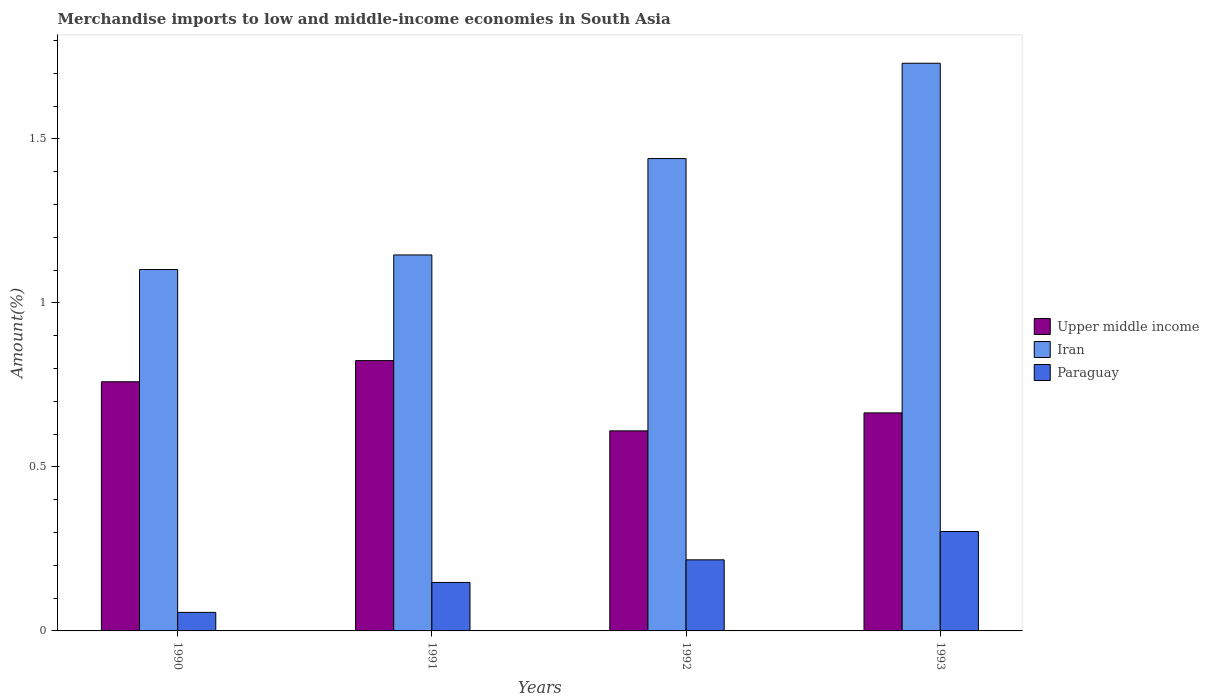How many different coloured bars are there?
Provide a short and direct response. 3. How many groups of bars are there?
Provide a short and direct response. 4. Are the number of bars per tick equal to the number of legend labels?
Offer a very short reply. Yes. Are the number of bars on each tick of the X-axis equal?
Your answer should be very brief. Yes. How many bars are there on the 3rd tick from the right?
Ensure brevity in your answer.  3. What is the percentage of amount earned from merchandise imports in Paraguay in 1990?
Your response must be concise. 0.06. Across all years, what is the maximum percentage of amount earned from merchandise imports in Paraguay?
Make the answer very short. 0.3. Across all years, what is the minimum percentage of amount earned from merchandise imports in Iran?
Offer a terse response. 1.1. In which year was the percentage of amount earned from merchandise imports in Iran maximum?
Your answer should be compact. 1993. What is the total percentage of amount earned from merchandise imports in Iran in the graph?
Offer a very short reply. 5.42. What is the difference between the percentage of amount earned from merchandise imports in Upper middle income in 1991 and that in 1992?
Keep it short and to the point. 0.21. What is the difference between the percentage of amount earned from merchandise imports in Paraguay in 1991 and the percentage of amount earned from merchandise imports in Upper middle income in 1990?
Offer a very short reply. -0.61. What is the average percentage of amount earned from merchandise imports in Iran per year?
Give a very brief answer. 1.35. In the year 1992, what is the difference between the percentage of amount earned from merchandise imports in Iran and percentage of amount earned from merchandise imports in Paraguay?
Your answer should be compact. 1.22. What is the ratio of the percentage of amount earned from merchandise imports in Upper middle income in 1990 to that in 1992?
Offer a terse response. 1.25. Is the percentage of amount earned from merchandise imports in Iran in 1992 less than that in 1993?
Make the answer very short. Yes. Is the difference between the percentage of amount earned from merchandise imports in Iran in 1990 and 1992 greater than the difference between the percentage of amount earned from merchandise imports in Paraguay in 1990 and 1992?
Provide a succinct answer. No. What is the difference between the highest and the second highest percentage of amount earned from merchandise imports in Iran?
Give a very brief answer. 0.29. What is the difference between the highest and the lowest percentage of amount earned from merchandise imports in Paraguay?
Give a very brief answer. 0.25. In how many years, is the percentage of amount earned from merchandise imports in Upper middle income greater than the average percentage of amount earned from merchandise imports in Upper middle income taken over all years?
Your answer should be compact. 2. Is the sum of the percentage of amount earned from merchandise imports in Upper middle income in 1990 and 1992 greater than the maximum percentage of amount earned from merchandise imports in Iran across all years?
Your response must be concise. No. What does the 2nd bar from the left in 1990 represents?
Your answer should be very brief. Iran. What does the 2nd bar from the right in 1992 represents?
Provide a short and direct response. Iran. Is it the case that in every year, the sum of the percentage of amount earned from merchandise imports in Paraguay and percentage of amount earned from merchandise imports in Upper middle income is greater than the percentage of amount earned from merchandise imports in Iran?
Offer a very short reply. No. How many bars are there?
Offer a very short reply. 12. Are the values on the major ticks of Y-axis written in scientific E-notation?
Offer a very short reply. No. How are the legend labels stacked?
Your response must be concise. Vertical. What is the title of the graph?
Give a very brief answer. Merchandise imports to low and middle-income economies in South Asia. Does "Slovak Republic" appear as one of the legend labels in the graph?
Provide a succinct answer. No. What is the label or title of the X-axis?
Provide a succinct answer. Years. What is the label or title of the Y-axis?
Give a very brief answer. Amount(%). What is the Amount(%) of Upper middle income in 1990?
Give a very brief answer. 0.76. What is the Amount(%) in Iran in 1990?
Your response must be concise. 1.1. What is the Amount(%) in Paraguay in 1990?
Your answer should be compact. 0.06. What is the Amount(%) of Upper middle income in 1991?
Offer a very short reply. 0.82. What is the Amount(%) in Iran in 1991?
Your response must be concise. 1.15. What is the Amount(%) in Paraguay in 1991?
Keep it short and to the point. 0.15. What is the Amount(%) of Upper middle income in 1992?
Offer a terse response. 0.61. What is the Amount(%) of Iran in 1992?
Provide a short and direct response. 1.44. What is the Amount(%) of Paraguay in 1992?
Provide a short and direct response. 0.22. What is the Amount(%) of Upper middle income in 1993?
Your answer should be compact. 0.66. What is the Amount(%) of Iran in 1993?
Offer a terse response. 1.73. What is the Amount(%) in Paraguay in 1993?
Provide a short and direct response. 0.3. Across all years, what is the maximum Amount(%) of Upper middle income?
Your answer should be compact. 0.82. Across all years, what is the maximum Amount(%) in Iran?
Your answer should be compact. 1.73. Across all years, what is the maximum Amount(%) of Paraguay?
Offer a very short reply. 0.3. Across all years, what is the minimum Amount(%) of Upper middle income?
Ensure brevity in your answer.  0.61. Across all years, what is the minimum Amount(%) of Iran?
Your response must be concise. 1.1. Across all years, what is the minimum Amount(%) in Paraguay?
Your answer should be very brief. 0.06. What is the total Amount(%) of Upper middle income in the graph?
Your response must be concise. 2.86. What is the total Amount(%) of Iran in the graph?
Keep it short and to the point. 5.42. What is the total Amount(%) in Paraguay in the graph?
Offer a very short reply. 0.72. What is the difference between the Amount(%) in Upper middle income in 1990 and that in 1991?
Provide a short and direct response. -0.06. What is the difference between the Amount(%) of Iran in 1990 and that in 1991?
Ensure brevity in your answer.  -0.04. What is the difference between the Amount(%) of Paraguay in 1990 and that in 1991?
Offer a terse response. -0.09. What is the difference between the Amount(%) in Upper middle income in 1990 and that in 1992?
Give a very brief answer. 0.15. What is the difference between the Amount(%) in Iran in 1990 and that in 1992?
Ensure brevity in your answer.  -0.34. What is the difference between the Amount(%) of Paraguay in 1990 and that in 1992?
Provide a short and direct response. -0.16. What is the difference between the Amount(%) of Upper middle income in 1990 and that in 1993?
Your answer should be compact. 0.09. What is the difference between the Amount(%) of Iran in 1990 and that in 1993?
Your answer should be very brief. -0.63. What is the difference between the Amount(%) of Paraguay in 1990 and that in 1993?
Your answer should be very brief. -0.25. What is the difference between the Amount(%) in Upper middle income in 1991 and that in 1992?
Your answer should be compact. 0.21. What is the difference between the Amount(%) of Iran in 1991 and that in 1992?
Your answer should be compact. -0.29. What is the difference between the Amount(%) of Paraguay in 1991 and that in 1992?
Offer a very short reply. -0.07. What is the difference between the Amount(%) of Upper middle income in 1991 and that in 1993?
Offer a very short reply. 0.16. What is the difference between the Amount(%) of Iran in 1991 and that in 1993?
Give a very brief answer. -0.58. What is the difference between the Amount(%) in Paraguay in 1991 and that in 1993?
Your response must be concise. -0.16. What is the difference between the Amount(%) in Upper middle income in 1992 and that in 1993?
Your answer should be very brief. -0.05. What is the difference between the Amount(%) of Iran in 1992 and that in 1993?
Offer a terse response. -0.29. What is the difference between the Amount(%) of Paraguay in 1992 and that in 1993?
Offer a terse response. -0.09. What is the difference between the Amount(%) of Upper middle income in 1990 and the Amount(%) of Iran in 1991?
Offer a terse response. -0.39. What is the difference between the Amount(%) in Upper middle income in 1990 and the Amount(%) in Paraguay in 1991?
Make the answer very short. 0.61. What is the difference between the Amount(%) in Iran in 1990 and the Amount(%) in Paraguay in 1991?
Keep it short and to the point. 0.95. What is the difference between the Amount(%) of Upper middle income in 1990 and the Amount(%) of Iran in 1992?
Your answer should be compact. -0.68. What is the difference between the Amount(%) of Upper middle income in 1990 and the Amount(%) of Paraguay in 1992?
Your answer should be very brief. 0.54. What is the difference between the Amount(%) in Iran in 1990 and the Amount(%) in Paraguay in 1992?
Your answer should be very brief. 0.89. What is the difference between the Amount(%) in Upper middle income in 1990 and the Amount(%) in Iran in 1993?
Provide a succinct answer. -0.97. What is the difference between the Amount(%) of Upper middle income in 1990 and the Amount(%) of Paraguay in 1993?
Offer a terse response. 0.46. What is the difference between the Amount(%) of Iran in 1990 and the Amount(%) of Paraguay in 1993?
Provide a succinct answer. 0.8. What is the difference between the Amount(%) of Upper middle income in 1991 and the Amount(%) of Iran in 1992?
Your response must be concise. -0.62. What is the difference between the Amount(%) in Upper middle income in 1991 and the Amount(%) in Paraguay in 1992?
Offer a terse response. 0.61. What is the difference between the Amount(%) in Iran in 1991 and the Amount(%) in Paraguay in 1992?
Your answer should be compact. 0.93. What is the difference between the Amount(%) in Upper middle income in 1991 and the Amount(%) in Iran in 1993?
Your response must be concise. -0.91. What is the difference between the Amount(%) in Upper middle income in 1991 and the Amount(%) in Paraguay in 1993?
Provide a short and direct response. 0.52. What is the difference between the Amount(%) of Iran in 1991 and the Amount(%) of Paraguay in 1993?
Keep it short and to the point. 0.84. What is the difference between the Amount(%) in Upper middle income in 1992 and the Amount(%) in Iran in 1993?
Offer a terse response. -1.12. What is the difference between the Amount(%) of Upper middle income in 1992 and the Amount(%) of Paraguay in 1993?
Provide a short and direct response. 0.31. What is the difference between the Amount(%) of Iran in 1992 and the Amount(%) of Paraguay in 1993?
Offer a terse response. 1.14. What is the average Amount(%) of Upper middle income per year?
Provide a short and direct response. 0.71. What is the average Amount(%) in Iran per year?
Offer a very short reply. 1.35. What is the average Amount(%) in Paraguay per year?
Keep it short and to the point. 0.18. In the year 1990, what is the difference between the Amount(%) in Upper middle income and Amount(%) in Iran?
Provide a short and direct response. -0.34. In the year 1990, what is the difference between the Amount(%) in Upper middle income and Amount(%) in Paraguay?
Ensure brevity in your answer.  0.7. In the year 1990, what is the difference between the Amount(%) of Iran and Amount(%) of Paraguay?
Your answer should be very brief. 1.05. In the year 1991, what is the difference between the Amount(%) in Upper middle income and Amount(%) in Iran?
Keep it short and to the point. -0.32. In the year 1991, what is the difference between the Amount(%) of Upper middle income and Amount(%) of Paraguay?
Make the answer very short. 0.68. In the year 1992, what is the difference between the Amount(%) of Upper middle income and Amount(%) of Iran?
Your response must be concise. -0.83. In the year 1992, what is the difference between the Amount(%) of Upper middle income and Amount(%) of Paraguay?
Your answer should be very brief. 0.39. In the year 1992, what is the difference between the Amount(%) in Iran and Amount(%) in Paraguay?
Give a very brief answer. 1.22. In the year 1993, what is the difference between the Amount(%) of Upper middle income and Amount(%) of Iran?
Provide a succinct answer. -1.07. In the year 1993, what is the difference between the Amount(%) of Upper middle income and Amount(%) of Paraguay?
Provide a succinct answer. 0.36. In the year 1993, what is the difference between the Amount(%) in Iran and Amount(%) in Paraguay?
Give a very brief answer. 1.43. What is the ratio of the Amount(%) of Upper middle income in 1990 to that in 1991?
Your response must be concise. 0.92. What is the ratio of the Amount(%) in Iran in 1990 to that in 1991?
Offer a very short reply. 0.96. What is the ratio of the Amount(%) of Paraguay in 1990 to that in 1991?
Give a very brief answer. 0.38. What is the ratio of the Amount(%) in Upper middle income in 1990 to that in 1992?
Your answer should be compact. 1.25. What is the ratio of the Amount(%) of Iran in 1990 to that in 1992?
Provide a short and direct response. 0.77. What is the ratio of the Amount(%) in Paraguay in 1990 to that in 1992?
Your answer should be very brief. 0.26. What is the ratio of the Amount(%) in Upper middle income in 1990 to that in 1993?
Your answer should be very brief. 1.14. What is the ratio of the Amount(%) in Iran in 1990 to that in 1993?
Offer a very short reply. 0.64. What is the ratio of the Amount(%) of Paraguay in 1990 to that in 1993?
Give a very brief answer. 0.19. What is the ratio of the Amount(%) of Upper middle income in 1991 to that in 1992?
Provide a succinct answer. 1.35. What is the ratio of the Amount(%) of Iran in 1991 to that in 1992?
Ensure brevity in your answer.  0.8. What is the ratio of the Amount(%) in Paraguay in 1991 to that in 1992?
Offer a very short reply. 0.68. What is the ratio of the Amount(%) in Upper middle income in 1991 to that in 1993?
Keep it short and to the point. 1.24. What is the ratio of the Amount(%) of Iran in 1991 to that in 1993?
Your answer should be compact. 0.66. What is the ratio of the Amount(%) of Paraguay in 1991 to that in 1993?
Provide a succinct answer. 0.49. What is the ratio of the Amount(%) of Upper middle income in 1992 to that in 1993?
Provide a short and direct response. 0.92. What is the ratio of the Amount(%) in Iran in 1992 to that in 1993?
Keep it short and to the point. 0.83. What is the ratio of the Amount(%) in Paraguay in 1992 to that in 1993?
Give a very brief answer. 0.71. What is the difference between the highest and the second highest Amount(%) in Upper middle income?
Provide a succinct answer. 0.06. What is the difference between the highest and the second highest Amount(%) of Iran?
Ensure brevity in your answer.  0.29. What is the difference between the highest and the second highest Amount(%) in Paraguay?
Ensure brevity in your answer.  0.09. What is the difference between the highest and the lowest Amount(%) of Upper middle income?
Make the answer very short. 0.21. What is the difference between the highest and the lowest Amount(%) in Iran?
Offer a very short reply. 0.63. What is the difference between the highest and the lowest Amount(%) of Paraguay?
Give a very brief answer. 0.25. 